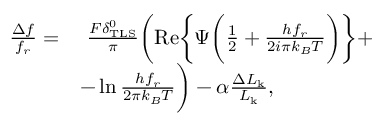Convert formula to latex. <formula><loc_0><loc_0><loc_500><loc_500>\begin{array} { r l } { \frac { \Delta f } { f _ { r } } = } & { \frac { F \delta _ { T L S } ^ { 0 } } { \pi } \left ( R e \left \{ \Psi \left ( \frac { 1 } { 2 } + \frac { h f _ { r } } { 2 i \pi k _ { B } T } \right ) \right \} + } \\ & { - \ln { \frac { h f _ { r } } { 2 \pi k _ { B } T } } \right ) - \alpha \frac { \Delta L _ { k } } { L _ { k } } , } \end{array}</formula> 